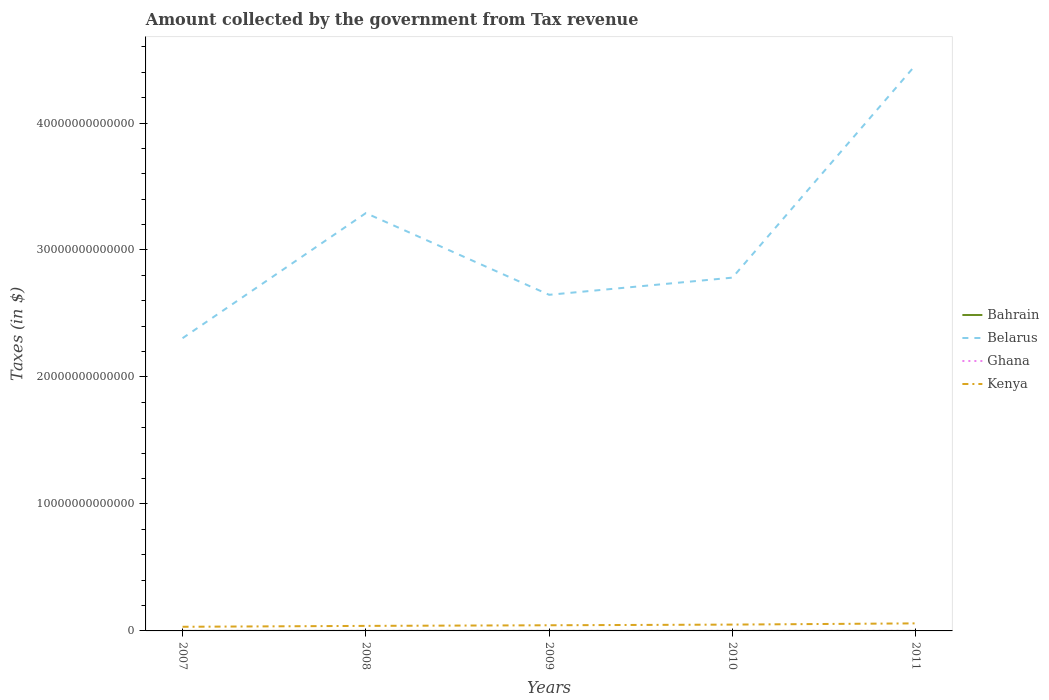How many different coloured lines are there?
Provide a succinct answer. 4. Is the number of lines equal to the number of legend labels?
Your answer should be very brief. Yes. Across all years, what is the maximum amount collected by the government from tax revenue in Kenya?
Ensure brevity in your answer.  3.26e+11. In which year was the amount collected by the government from tax revenue in Ghana maximum?
Keep it short and to the point. 2007. What is the total amount collected by the government from tax revenue in Bahrain in the graph?
Offer a very short reply. -2.02e+07. What is the difference between the highest and the second highest amount collected by the government from tax revenue in Bahrain?
Your response must be concise. 2.70e+07. How many lines are there?
Provide a succinct answer. 4. What is the difference between two consecutive major ticks on the Y-axis?
Provide a succinct answer. 1.00e+13. How many legend labels are there?
Your answer should be very brief. 4. How are the legend labels stacked?
Provide a short and direct response. Vertical. What is the title of the graph?
Provide a short and direct response. Amount collected by the government from Tax revenue. Does "Sierra Leone" appear as one of the legend labels in the graph?
Your answer should be very brief. No. What is the label or title of the X-axis?
Provide a succinct answer. Years. What is the label or title of the Y-axis?
Your answer should be compact. Taxes (in $). What is the Taxes (in $) in Bahrain in 2007?
Ensure brevity in your answer.  9.36e+07. What is the Taxes (in $) of Belarus in 2007?
Keep it short and to the point. 2.31e+13. What is the Taxes (in $) of Ghana in 2007?
Keep it short and to the point. 3.21e+09. What is the Taxes (in $) of Kenya in 2007?
Provide a succinct answer. 3.26e+11. What is the Taxes (in $) in Bahrain in 2008?
Your response must be concise. 1.19e+08. What is the Taxes (in $) of Belarus in 2008?
Offer a terse response. 3.29e+13. What is the Taxes (in $) in Ghana in 2008?
Keep it short and to the point. 4.19e+09. What is the Taxes (in $) in Kenya in 2008?
Offer a very short reply. 3.96e+11. What is the Taxes (in $) of Bahrain in 2009?
Offer a terse response. 1.18e+08. What is the Taxes (in $) in Belarus in 2009?
Provide a succinct answer. 2.65e+13. What is the Taxes (in $) in Ghana in 2009?
Provide a succinct answer. 4.62e+09. What is the Taxes (in $) in Kenya in 2009?
Ensure brevity in your answer.  4.45e+11. What is the Taxes (in $) of Bahrain in 2010?
Keep it short and to the point. 1.14e+08. What is the Taxes (in $) of Belarus in 2010?
Provide a short and direct response. 2.78e+13. What is the Taxes (in $) of Ghana in 2010?
Offer a terse response. 6.16e+09. What is the Taxes (in $) in Kenya in 2010?
Offer a terse response. 4.99e+11. What is the Taxes (in $) in Bahrain in 2011?
Provide a succinct answer. 1.21e+08. What is the Taxes (in $) in Belarus in 2011?
Keep it short and to the point. 4.46e+13. What is the Taxes (in $) in Ghana in 2011?
Give a very brief answer. 8.89e+09. What is the Taxes (in $) of Kenya in 2011?
Keep it short and to the point. 5.94e+11. Across all years, what is the maximum Taxes (in $) in Bahrain?
Your response must be concise. 1.21e+08. Across all years, what is the maximum Taxes (in $) in Belarus?
Provide a short and direct response. 4.46e+13. Across all years, what is the maximum Taxes (in $) in Ghana?
Provide a short and direct response. 8.89e+09. Across all years, what is the maximum Taxes (in $) in Kenya?
Your response must be concise. 5.94e+11. Across all years, what is the minimum Taxes (in $) in Bahrain?
Your answer should be compact. 9.36e+07. Across all years, what is the minimum Taxes (in $) of Belarus?
Provide a succinct answer. 2.31e+13. Across all years, what is the minimum Taxes (in $) in Ghana?
Ensure brevity in your answer.  3.21e+09. Across all years, what is the minimum Taxes (in $) in Kenya?
Give a very brief answer. 3.26e+11. What is the total Taxes (in $) of Bahrain in the graph?
Ensure brevity in your answer.  5.65e+08. What is the total Taxes (in $) in Belarus in the graph?
Give a very brief answer. 1.55e+14. What is the total Taxes (in $) in Ghana in the graph?
Your answer should be compact. 2.71e+1. What is the total Taxes (in $) in Kenya in the graph?
Offer a terse response. 2.26e+12. What is the difference between the Taxes (in $) in Bahrain in 2007 and that in 2008?
Offer a very short reply. -2.59e+07. What is the difference between the Taxes (in $) in Belarus in 2007 and that in 2008?
Give a very brief answer. -9.85e+12. What is the difference between the Taxes (in $) of Ghana in 2007 and that in 2008?
Make the answer very short. -9.80e+08. What is the difference between the Taxes (in $) of Kenya in 2007 and that in 2008?
Provide a succinct answer. -7.02e+1. What is the difference between the Taxes (in $) in Bahrain in 2007 and that in 2009?
Offer a terse response. -2.40e+07. What is the difference between the Taxes (in $) of Belarus in 2007 and that in 2009?
Your answer should be compact. -3.42e+12. What is the difference between the Taxes (in $) of Ghana in 2007 and that in 2009?
Ensure brevity in your answer.  -1.40e+09. What is the difference between the Taxes (in $) of Kenya in 2007 and that in 2009?
Offer a very short reply. -1.19e+11. What is the difference between the Taxes (in $) of Bahrain in 2007 and that in 2010?
Ensure brevity in your answer.  -2.02e+07. What is the difference between the Taxes (in $) of Belarus in 2007 and that in 2010?
Offer a very short reply. -4.77e+12. What is the difference between the Taxes (in $) in Ghana in 2007 and that in 2010?
Keep it short and to the point. -2.95e+09. What is the difference between the Taxes (in $) in Kenya in 2007 and that in 2010?
Your response must be concise. -1.72e+11. What is the difference between the Taxes (in $) of Bahrain in 2007 and that in 2011?
Give a very brief answer. -2.70e+07. What is the difference between the Taxes (in $) in Belarus in 2007 and that in 2011?
Keep it short and to the point. -2.15e+13. What is the difference between the Taxes (in $) in Ghana in 2007 and that in 2011?
Make the answer very short. -5.68e+09. What is the difference between the Taxes (in $) in Kenya in 2007 and that in 2011?
Provide a short and direct response. -2.68e+11. What is the difference between the Taxes (in $) in Bahrain in 2008 and that in 2009?
Your answer should be very brief. 1.90e+06. What is the difference between the Taxes (in $) of Belarus in 2008 and that in 2009?
Offer a terse response. 6.44e+12. What is the difference between the Taxes (in $) in Ghana in 2008 and that in 2009?
Offer a terse response. -4.22e+08. What is the difference between the Taxes (in $) of Kenya in 2008 and that in 2009?
Your answer should be compact. -4.88e+1. What is the difference between the Taxes (in $) in Bahrain in 2008 and that in 2010?
Your answer should be very brief. 5.75e+06. What is the difference between the Taxes (in $) in Belarus in 2008 and that in 2010?
Provide a succinct answer. 5.08e+12. What is the difference between the Taxes (in $) of Ghana in 2008 and that in 2010?
Your answer should be very brief. -1.97e+09. What is the difference between the Taxes (in $) in Kenya in 2008 and that in 2010?
Offer a terse response. -1.02e+11. What is the difference between the Taxes (in $) of Bahrain in 2008 and that in 2011?
Your response must be concise. -1.08e+06. What is the difference between the Taxes (in $) in Belarus in 2008 and that in 2011?
Your answer should be very brief. -1.17e+13. What is the difference between the Taxes (in $) of Ghana in 2008 and that in 2011?
Give a very brief answer. -4.70e+09. What is the difference between the Taxes (in $) in Kenya in 2008 and that in 2011?
Your answer should be very brief. -1.98e+11. What is the difference between the Taxes (in $) in Bahrain in 2009 and that in 2010?
Offer a very short reply. 3.85e+06. What is the difference between the Taxes (in $) of Belarus in 2009 and that in 2010?
Your answer should be compact. -1.35e+12. What is the difference between the Taxes (in $) in Ghana in 2009 and that in 2010?
Ensure brevity in your answer.  -1.55e+09. What is the difference between the Taxes (in $) of Kenya in 2009 and that in 2010?
Make the answer very short. -5.35e+1. What is the difference between the Taxes (in $) of Bahrain in 2009 and that in 2011?
Ensure brevity in your answer.  -2.98e+06. What is the difference between the Taxes (in $) in Belarus in 2009 and that in 2011?
Provide a short and direct response. -1.81e+13. What is the difference between the Taxes (in $) of Ghana in 2009 and that in 2011?
Your answer should be compact. -4.28e+09. What is the difference between the Taxes (in $) in Kenya in 2009 and that in 2011?
Your answer should be very brief. -1.49e+11. What is the difference between the Taxes (in $) of Bahrain in 2010 and that in 2011?
Offer a very short reply. -6.83e+06. What is the difference between the Taxes (in $) in Belarus in 2010 and that in 2011?
Provide a short and direct response. -1.68e+13. What is the difference between the Taxes (in $) in Ghana in 2010 and that in 2011?
Provide a succinct answer. -2.73e+09. What is the difference between the Taxes (in $) in Kenya in 2010 and that in 2011?
Keep it short and to the point. -9.56e+1. What is the difference between the Taxes (in $) of Bahrain in 2007 and the Taxes (in $) of Belarus in 2008?
Make the answer very short. -3.29e+13. What is the difference between the Taxes (in $) of Bahrain in 2007 and the Taxes (in $) of Ghana in 2008?
Ensure brevity in your answer.  -4.10e+09. What is the difference between the Taxes (in $) in Bahrain in 2007 and the Taxes (in $) in Kenya in 2008?
Make the answer very short. -3.96e+11. What is the difference between the Taxes (in $) of Belarus in 2007 and the Taxes (in $) of Ghana in 2008?
Your answer should be compact. 2.30e+13. What is the difference between the Taxes (in $) of Belarus in 2007 and the Taxes (in $) of Kenya in 2008?
Keep it short and to the point. 2.27e+13. What is the difference between the Taxes (in $) of Ghana in 2007 and the Taxes (in $) of Kenya in 2008?
Offer a very short reply. -3.93e+11. What is the difference between the Taxes (in $) in Bahrain in 2007 and the Taxes (in $) in Belarus in 2009?
Provide a succinct answer. -2.65e+13. What is the difference between the Taxes (in $) in Bahrain in 2007 and the Taxes (in $) in Ghana in 2009?
Offer a very short reply. -4.52e+09. What is the difference between the Taxes (in $) in Bahrain in 2007 and the Taxes (in $) in Kenya in 2009?
Provide a succinct answer. -4.45e+11. What is the difference between the Taxes (in $) in Belarus in 2007 and the Taxes (in $) in Ghana in 2009?
Give a very brief answer. 2.30e+13. What is the difference between the Taxes (in $) in Belarus in 2007 and the Taxes (in $) in Kenya in 2009?
Make the answer very short. 2.26e+13. What is the difference between the Taxes (in $) in Ghana in 2007 and the Taxes (in $) in Kenya in 2009?
Offer a very short reply. -4.42e+11. What is the difference between the Taxes (in $) of Bahrain in 2007 and the Taxes (in $) of Belarus in 2010?
Your answer should be compact. -2.78e+13. What is the difference between the Taxes (in $) in Bahrain in 2007 and the Taxes (in $) in Ghana in 2010?
Offer a terse response. -6.07e+09. What is the difference between the Taxes (in $) of Bahrain in 2007 and the Taxes (in $) of Kenya in 2010?
Keep it short and to the point. -4.99e+11. What is the difference between the Taxes (in $) of Belarus in 2007 and the Taxes (in $) of Ghana in 2010?
Your answer should be very brief. 2.30e+13. What is the difference between the Taxes (in $) of Belarus in 2007 and the Taxes (in $) of Kenya in 2010?
Give a very brief answer. 2.26e+13. What is the difference between the Taxes (in $) of Ghana in 2007 and the Taxes (in $) of Kenya in 2010?
Your answer should be compact. -4.95e+11. What is the difference between the Taxes (in $) of Bahrain in 2007 and the Taxes (in $) of Belarus in 2011?
Ensure brevity in your answer.  -4.46e+13. What is the difference between the Taxes (in $) in Bahrain in 2007 and the Taxes (in $) in Ghana in 2011?
Ensure brevity in your answer.  -8.80e+09. What is the difference between the Taxes (in $) of Bahrain in 2007 and the Taxes (in $) of Kenya in 2011?
Provide a succinct answer. -5.94e+11. What is the difference between the Taxes (in $) of Belarus in 2007 and the Taxes (in $) of Ghana in 2011?
Your response must be concise. 2.30e+13. What is the difference between the Taxes (in $) of Belarus in 2007 and the Taxes (in $) of Kenya in 2011?
Your answer should be compact. 2.25e+13. What is the difference between the Taxes (in $) of Ghana in 2007 and the Taxes (in $) of Kenya in 2011?
Offer a very short reply. -5.91e+11. What is the difference between the Taxes (in $) in Bahrain in 2008 and the Taxes (in $) in Belarus in 2009?
Give a very brief answer. -2.65e+13. What is the difference between the Taxes (in $) in Bahrain in 2008 and the Taxes (in $) in Ghana in 2009?
Offer a very short reply. -4.50e+09. What is the difference between the Taxes (in $) of Bahrain in 2008 and the Taxes (in $) of Kenya in 2009?
Offer a very short reply. -4.45e+11. What is the difference between the Taxes (in $) in Belarus in 2008 and the Taxes (in $) in Ghana in 2009?
Keep it short and to the point. 3.29e+13. What is the difference between the Taxes (in $) of Belarus in 2008 and the Taxes (in $) of Kenya in 2009?
Your answer should be very brief. 3.25e+13. What is the difference between the Taxes (in $) of Ghana in 2008 and the Taxes (in $) of Kenya in 2009?
Give a very brief answer. -4.41e+11. What is the difference between the Taxes (in $) of Bahrain in 2008 and the Taxes (in $) of Belarus in 2010?
Give a very brief answer. -2.78e+13. What is the difference between the Taxes (in $) of Bahrain in 2008 and the Taxes (in $) of Ghana in 2010?
Provide a short and direct response. -6.04e+09. What is the difference between the Taxes (in $) in Bahrain in 2008 and the Taxes (in $) in Kenya in 2010?
Give a very brief answer. -4.99e+11. What is the difference between the Taxes (in $) in Belarus in 2008 and the Taxes (in $) in Ghana in 2010?
Your response must be concise. 3.29e+13. What is the difference between the Taxes (in $) of Belarus in 2008 and the Taxes (in $) of Kenya in 2010?
Provide a succinct answer. 3.24e+13. What is the difference between the Taxes (in $) in Ghana in 2008 and the Taxes (in $) in Kenya in 2010?
Offer a very short reply. -4.94e+11. What is the difference between the Taxes (in $) in Bahrain in 2008 and the Taxes (in $) in Belarus in 2011?
Make the answer very short. -4.46e+13. What is the difference between the Taxes (in $) in Bahrain in 2008 and the Taxes (in $) in Ghana in 2011?
Ensure brevity in your answer.  -8.77e+09. What is the difference between the Taxes (in $) of Bahrain in 2008 and the Taxes (in $) of Kenya in 2011?
Ensure brevity in your answer.  -5.94e+11. What is the difference between the Taxes (in $) in Belarus in 2008 and the Taxes (in $) in Ghana in 2011?
Your answer should be very brief. 3.29e+13. What is the difference between the Taxes (in $) in Belarus in 2008 and the Taxes (in $) in Kenya in 2011?
Provide a succinct answer. 3.23e+13. What is the difference between the Taxes (in $) in Ghana in 2008 and the Taxes (in $) in Kenya in 2011?
Give a very brief answer. -5.90e+11. What is the difference between the Taxes (in $) of Bahrain in 2009 and the Taxes (in $) of Belarus in 2010?
Offer a very short reply. -2.78e+13. What is the difference between the Taxes (in $) of Bahrain in 2009 and the Taxes (in $) of Ghana in 2010?
Your answer should be compact. -6.05e+09. What is the difference between the Taxes (in $) in Bahrain in 2009 and the Taxes (in $) in Kenya in 2010?
Provide a succinct answer. -4.99e+11. What is the difference between the Taxes (in $) in Belarus in 2009 and the Taxes (in $) in Ghana in 2010?
Keep it short and to the point. 2.65e+13. What is the difference between the Taxes (in $) in Belarus in 2009 and the Taxes (in $) in Kenya in 2010?
Provide a short and direct response. 2.60e+13. What is the difference between the Taxes (in $) in Ghana in 2009 and the Taxes (in $) in Kenya in 2010?
Give a very brief answer. -4.94e+11. What is the difference between the Taxes (in $) in Bahrain in 2009 and the Taxes (in $) in Belarus in 2011?
Your answer should be very brief. -4.46e+13. What is the difference between the Taxes (in $) of Bahrain in 2009 and the Taxes (in $) of Ghana in 2011?
Your answer should be very brief. -8.77e+09. What is the difference between the Taxes (in $) of Bahrain in 2009 and the Taxes (in $) of Kenya in 2011?
Keep it short and to the point. -5.94e+11. What is the difference between the Taxes (in $) of Belarus in 2009 and the Taxes (in $) of Ghana in 2011?
Make the answer very short. 2.65e+13. What is the difference between the Taxes (in $) of Belarus in 2009 and the Taxes (in $) of Kenya in 2011?
Your response must be concise. 2.59e+13. What is the difference between the Taxes (in $) in Ghana in 2009 and the Taxes (in $) in Kenya in 2011?
Your answer should be compact. -5.90e+11. What is the difference between the Taxes (in $) in Bahrain in 2010 and the Taxes (in $) in Belarus in 2011?
Provide a succinct answer. -4.46e+13. What is the difference between the Taxes (in $) in Bahrain in 2010 and the Taxes (in $) in Ghana in 2011?
Offer a terse response. -8.78e+09. What is the difference between the Taxes (in $) in Bahrain in 2010 and the Taxes (in $) in Kenya in 2011?
Your response must be concise. -5.94e+11. What is the difference between the Taxes (in $) of Belarus in 2010 and the Taxes (in $) of Ghana in 2011?
Provide a succinct answer. 2.78e+13. What is the difference between the Taxes (in $) of Belarus in 2010 and the Taxes (in $) of Kenya in 2011?
Provide a short and direct response. 2.72e+13. What is the difference between the Taxes (in $) in Ghana in 2010 and the Taxes (in $) in Kenya in 2011?
Your response must be concise. -5.88e+11. What is the average Taxes (in $) of Bahrain per year?
Keep it short and to the point. 1.13e+08. What is the average Taxes (in $) of Belarus per year?
Offer a very short reply. 3.10e+13. What is the average Taxes (in $) in Ghana per year?
Your answer should be very brief. 5.42e+09. What is the average Taxes (in $) of Kenya per year?
Provide a short and direct response. 4.52e+11. In the year 2007, what is the difference between the Taxes (in $) of Bahrain and Taxes (in $) of Belarus?
Provide a short and direct response. -2.31e+13. In the year 2007, what is the difference between the Taxes (in $) in Bahrain and Taxes (in $) in Ghana?
Your response must be concise. -3.12e+09. In the year 2007, what is the difference between the Taxes (in $) in Bahrain and Taxes (in $) in Kenya?
Offer a terse response. -3.26e+11. In the year 2007, what is the difference between the Taxes (in $) in Belarus and Taxes (in $) in Ghana?
Your response must be concise. 2.31e+13. In the year 2007, what is the difference between the Taxes (in $) in Belarus and Taxes (in $) in Kenya?
Your response must be concise. 2.27e+13. In the year 2007, what is the difference between the Taxes (in $) of Ghana and Taxes (in $) of Kenya?
Your answer should be very brief. -3.23e+11. In the year 2008, what is the difference between the Taxes (in $) of Bahrain and Taxes (in $) of Belarus?
Your answer should be very brief. -3.29e+13. In the year 2008, what is the difference between the Taxes (in $) of Bahrain and Taxes (in $) of Ghana?
Make the answer very short. -4.07e+09. In the year 2008, what is the difference between the Taxes (in $) of Bahrain and Taxes (in $) of Kenya?
Ensure brevity in your answer.  -3.96e+11. In the year 2008, what is the difference between the Taxes (in $) of Belarus and Taxes (in $) of Ghana?
Keep it short and to the point. 3.29e+13. In the year 2008, what is the difference between the Taxes (in $) in Belarus and Taxes (in $) in Kenya?
Offer a very short reply. 3.25e+13. In the year 2008, what is the difference between the Taxes (in $) in Ghana and Taxes (in $) in Kenya?
Keep it short and to the point. -3.92e+11. In the year 2009, what is the difference between the Taxes (in $) of Bahrain and Taxes (in $) of Belarus?
Your answer should be very brief. -2.65e+13. In the year 2009, what is the difference between the Taxes (in $) of Bahrain and Taxes (in $) of Ghana?
Your answer should be very brief. -4.50e+09. In the year 2009, what is the difference between the Taxes (in $) of Bahrain and Taxes (in $) of Kenya?
Give a very brief answer. -4.45e+11. In the year 2009, what is the difference between the Taxes (in $) in Belarus and Taxes (in $) in Ghana?
Provide a succinct answer. 2.65e+13. In the year 2009, what is the difference between the Taxes (in $) of Belarus and Taxes (in $) of Kenya?
Give a very brief answer. 2.60e+13. In the year 2009, what is the difference between the Taxes (in $) of Ghana and Taxes (in $) of Kenya?
Your answer should be very brief. -4.41e+11. In the year 2010, what is the difference between the Taxes (in $) in Bahrain and Taxes (in $) in Belarus?
Give a very brief answer. -2.78e+13. In the year 2010, what is the difference between the Taxes (in $) of Bahrain and Taxes (in $) of Ghana?
Your answer should be very brief. -6.05e+09. In the year 2010, what is the difference between the Taxes (in $) of Bahrain and Taxes (in $) of Kenya?
Ensure brevity in your answer.  -4.99e+11. In the year 2010, what is the difference between the Taxes (in $) of Belarus and Taxes (in $) of Ghana?
Ensure brevity in your answer.  2.78e+13. In the year 2010, what is the difference between the Taxes (in $) of Belarus and Taxes (in $) of Kenya?
Your response must be concise. 2.73e+13. In the year 2010, what is the difference between the Taxes (in $) in Ghana and Taxes (in $) in Kenya?
Offer a terse response. -4.92e+11. In the year 2011, what is the difference between the Taxes (in $) in Bahrain and Taxes (in $) in Belarus?
Offer a very short reply. -4.46e+13. In the year 2011, what is the difference between the Taxes (in $) of Bahrain and Taxes (in $) of Ghana?
Your answer should be very brief. -8.77e+09. In the year 2011, what is the difference between the Taxes (in $) in Bahrain and Taxes (in $) in Kenya?
Make the answer very short. -5.94e+11. In the year 2011, what is the difference between the Taxes (in $) of Belarus and Taxes (in $) of Ghana?
Keep it short and to the point. 4.46e+13. In the year 2011, what is the difference between the Taxes (in $) in Belarus and Taxes (in $) in Kenya?
Provide a succinct answer. 4.40e+13. In the year 2011, what is the difference between the Taxes (in $) of Ghana and Taxes (in $) of Kenya?
Ensure brevity in your answer.  -5.85e+11. What is the ratio of the Taxes (in $) of Bahrain in 2007 to that in 2008?
Your answer should be compact. 0.78. What is the ratio of the Taxes (in $) of Belarus in 2007 to that in 2008?
Your answer should be very brief. 0.7. What is the ratio of the Taxes (in $) in Ghana in 2007 to that in 2008?
Offer a very short reply. 0.77. What is the ratio of the Taxes (in $) of Kenya in 2007 to that in 2008?
Give a very brief answer. 0.82. What is the ratio of the Taxes (in $) in Bahrain in 2007 to that in 2009?
Make the answer very short. 0.8. What is the ratio of the Taxes (in $) of Belarus in 2007 to that in 2009?
Offer a very short reply. 0.87. What is the ratio of the Taxes (in $) in Ghana in 2007 to that in 2009?
Provide a short and direct response. 0.7. What is the ratio of the Taxes (in $) of Kenya in 2007 to that in 2009?
Your response must be concise. 0.73. What is the ratio of the Taxes (in $) in Bahrain in 2007 to that in 2010?
Your answer should be compact. 0.82. What is the ratio of the Taxes (in $) in Belarus in 2007 to that in 2010?
Offer a terse response. 0.83. What is the ratio of the Taxes (in $) in Ghana in 2007 to that in 2010?
Ensure brevity in your answer.  0.52. What is the ratio of the Taxes (in $) in Kenya in 2007 to that in 2010?
Offer a very short reply. 0.65. What is the ratio of the Taxes (in $) in Bahrain in 2007 to that in 2011?
Your answer should be very brief. 0.78. What is the ratio of the Taxes (in $) in Belarus in 2007 to that in 2011?
Offer a terse response. 0.52. What is the ratio of the Taxes (in $) in Ghana in 2007 to that in 2011?
Ensure brevity in your answer.  0.36. What is the ratio of the Taxes (in $) in Kenya in 2007 to that in 2011?
Ensure brevity in your answer.  0.55. What is the ratio of the Taxes (in $) in Bahrain in 2008 to that in 2009?
Ensure brevity in your answer.  1.02. What is the ratio of the Taxes (in $) of Belarus in 2008 to that in 2009?
Keep it short and to the point. 1.24. What is the ratio of the Taxes (in $) in Ghana in 2008 to that in 2009?
Offer a very short reply. 0.91. What is the ratio of the Taxes (in $) in Kenya in 2008 to that in 2009?
Keep it short and to the point. 0.89. What is the ratio of the Taxes (in $) of Bahrain in 2008 to that in 2010?
Provide a succinct answer. 1.05. What is the ratio of the Taxes (in $) in Belarus in 2008 to that in 2010?
Your response must be concise. 1.18. What is the ratio of the Taxes (in $) in Ghana in 2008 to that in 2010?
Provide a succinct answer. 0.68. What is the ratio of the Taxes (in $) of Kenya in 2008 to that in 2010?
Give a very brief answer. 0.79. What is the ratio of the Taxes (in $) of Bahrain in 2008 to that in 2011?
Your answer should be compact. 0.99. What is the ratio of the Taxes (in $) of Belarus in 2008 to that in 2011?
Your answer should be very brief. 0.74. What is the ratio of the Taxes (in $) of Ghana in 2008 to that in 2011?
Offer a terse response. 0.47. What is the ratio of the Taxes (in $) of Kenya in 2008 to that in 2011?
Keep it short and to the point. 0.67. What is the ratio of the Taxes (in $) in Bahrain in 2009 to that in 2010?
Your answer should be very brief. 1.03. What is the ratio of the Taxes (in $) in Belarus in 2009 to that in 2010?
Keep it short and to the point. 0.95. What is the ratio of the Taxes (in $) of Ghana in 2009 to that in 2010?
Your answer should be very brief. 0.75. What is the ratio of the Taxes (in $) of Kenya in 2009 to that in 2010?
Your answer should be compact. 0.89. What is the ratio of the Taxes (in $) in Bahrain in 2009 to that in 2011?
Offer a terse response. 0.98. What is the ratio of the Taxes (in $) in Belarus in 2009 to that in 2011?
Your answer should be very brief. 0.59. What is the ratio of the Taxes (in $) of Ghana in 2009 to that in 2011?
Make the answer very short. 0.52. What is the ratio of the Taxes (in $) of Kenya in 2009 to that in 2011?
Ensure brevity in your answer.  0.75. What is the ratio of the Taxes (in $) of Bahrain in 2010 to that in 2011?
Your answer should be compact. 0.94. What is the ratio of the Taxes (in $) of Belarus in 2010 to that in 2011?
Provide a succinct answer. 0.62. What is the ratio of the Taxes (in $) of Ghana in 2010 to that in 2011?
Provide a short and direct response. 0.69. What is the ratio of the Taxes (in $) in Kenya in 2010 to that in 2011?
Ensure brevity in your answer.  0.84. What is the difference between the highest and the second highest Taxes (in $) in Bahrain?
Ensure brevity in your answer.  1.08e+06. What is the difference between the highest and the second highest Taxes (in $) in Belarus?
Your response must be concise. 1.17e+13. What is the difference between the highest and the second highest Taxes (in $) of Ghana?
Offer a terse response. 2.73e+09. What is the difference between the highest and the second highest Taxes (in $) of Kenya?
Your response must be concise. 9.56e+1. What is the difference between the highest and the lowest Taxes (in $) in Bahrain?
Ensure brevity in your answer.  2.70e+07. What is the difference between the highest and the lowest Taxes (in $) in Belarus?
Offer a terse response. 2.15e+13. What is the difference between the highest and the lowest Taxes (in $) in Ghana?
Make the answer very short. 5.68e+09. What is the difference between the highest and the lowest Taxes (in $) in Kenya?
Provide a short and direct response. 2.68e+11. 